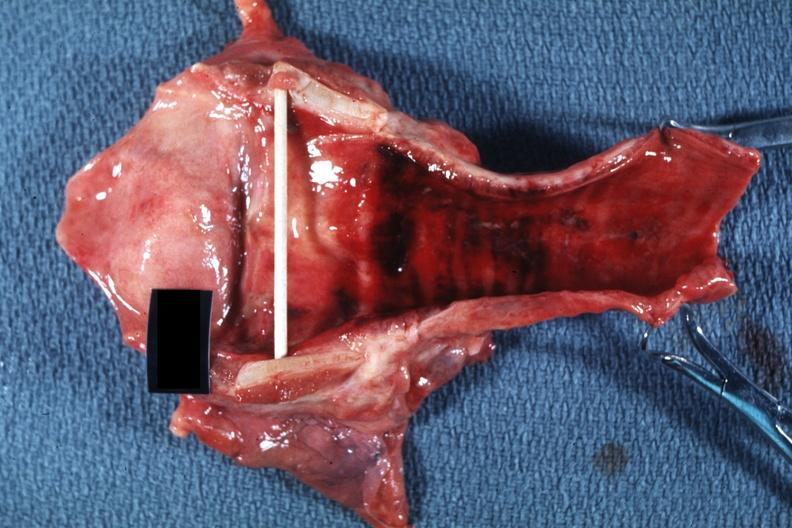s pinworm present?
Answer the question using a single word or phrase. No 